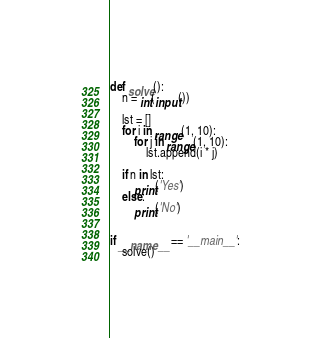Convert code to text. <code><loc_0><loc_0><loc_500><loc_500><_Python_>def solve():
    n = int(input())

    lst = []
    for i in range(1, 10):
        for j in range(1, 10):
            lst.append(i * j)

    if n in lst:
        print('Yes')
    else:
        print('No')


if __name__ == '__main__':
    solve()
</code> 